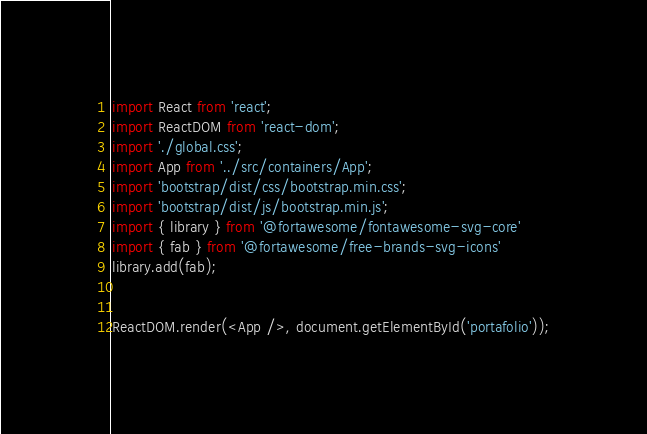Convert code to text. <code><loc_0><loc_0><loc_500><loc_500><_JavaScript_>import React from 'react';
import ReactDOM from 'react-dom';
import './global.css';
import App from '../src/containers/App';
import 'bootstrap/dist/css/bootstrap.min.css';
import 'bootstrap/dist/js/bootstrap.min.js';
import { library } from '@fortawesome/fontawesome-svg-core'
import { fab } from '@fortawesome/free-brands-svg-icons'
library.add(fab);

 
ReactDOM.render(<App />, document.getElementById('portafolio'));
</code> 